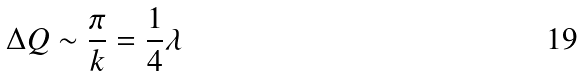Convert formula to latex. <formula><loc_0><loc_0><loc_500><loc_500>\Delta Q \sim \frac { \pi } { k } = \frac { 1 } { 4 } \lambda</formula> 